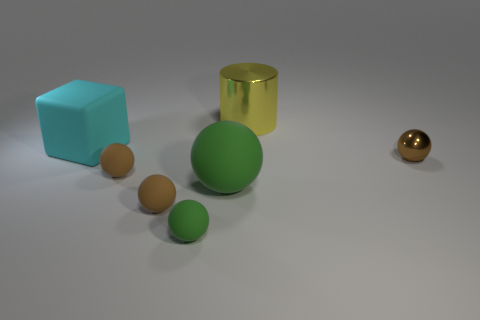Subtract all small green spheres. How many spheres are left? 4 Subtract all green spheres. How many spheres are left? 3 Add 1 tiny brown balls. How many objects exist? 8 Subtract 1 balls. How many balls are left? 4 Subtract all balls. How many objects are left? 2 Subtract all yellow spheres. Subtract all brown cylinders. How many spheres are left? 5 Subtract all cyan cylinders. How many purple blocks are left? 0 Subtract all large yellow cylinders. Subtract all cyan rubber things. How many objects are left? 5 Add 5 brown spheres. How many brown spheres are left? 8 Add 7 large green matte spheres. How many large green matte spheres exist? 8 